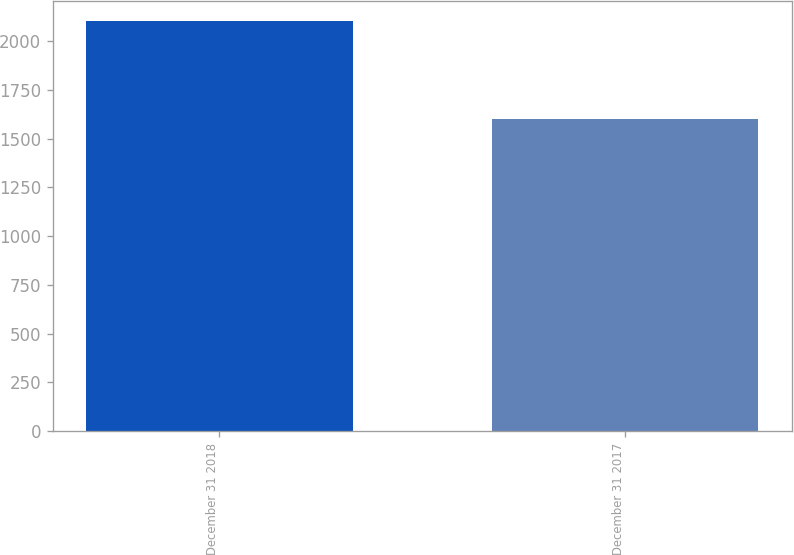Convert chart. <chart><loc_0><loc_0><loc_500><loc_500><bar_chart><fcel>December 31 2018<fcel>December 31 2017<nl><fcel>2100<fcel>1600<nl></chart> 